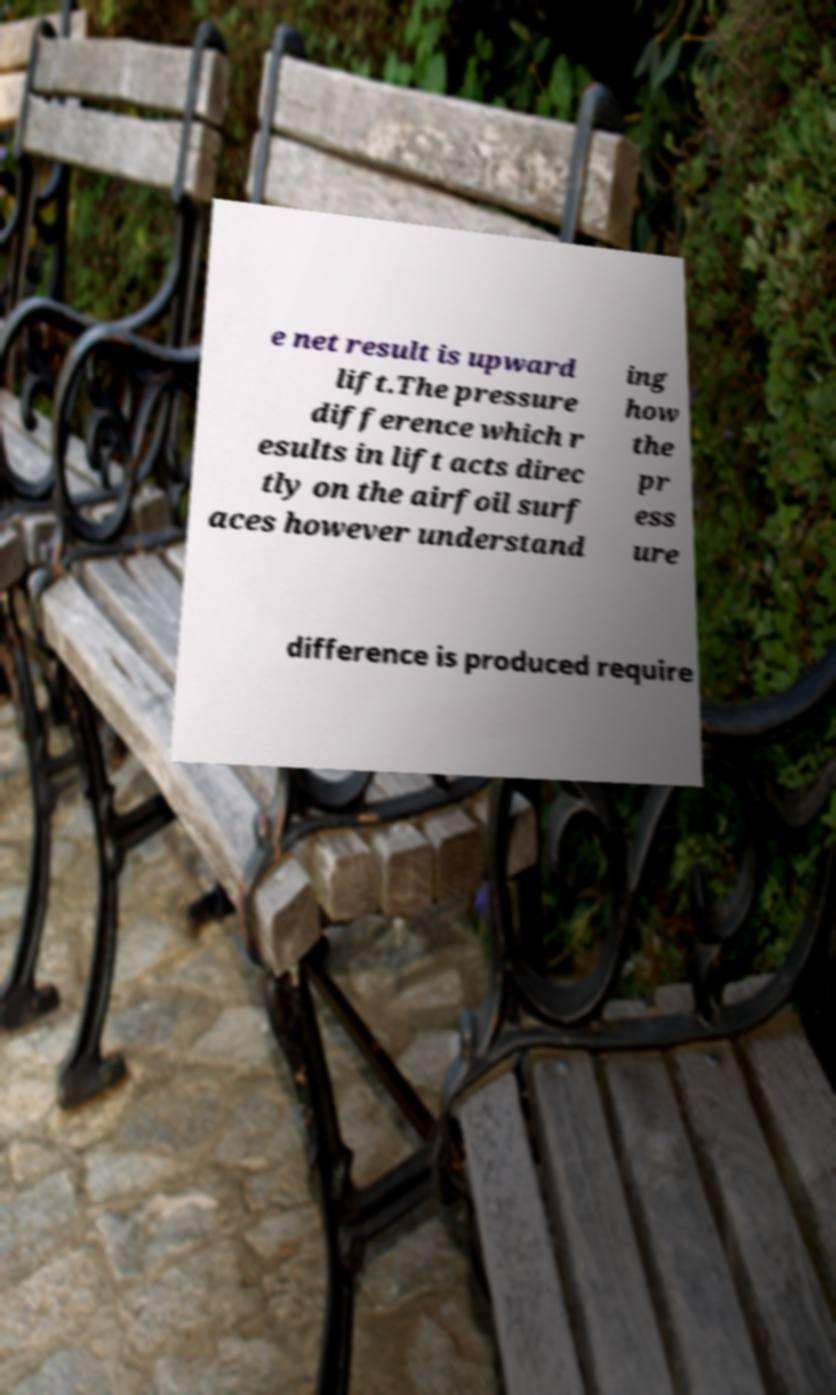Please read and relay the text visible in this image. What does it say? e net result is upward lift.The pressure difference which r esults in lift acts direc tly on the airfoil surf aces however understand ing how the pr ess ure difference is produced require 